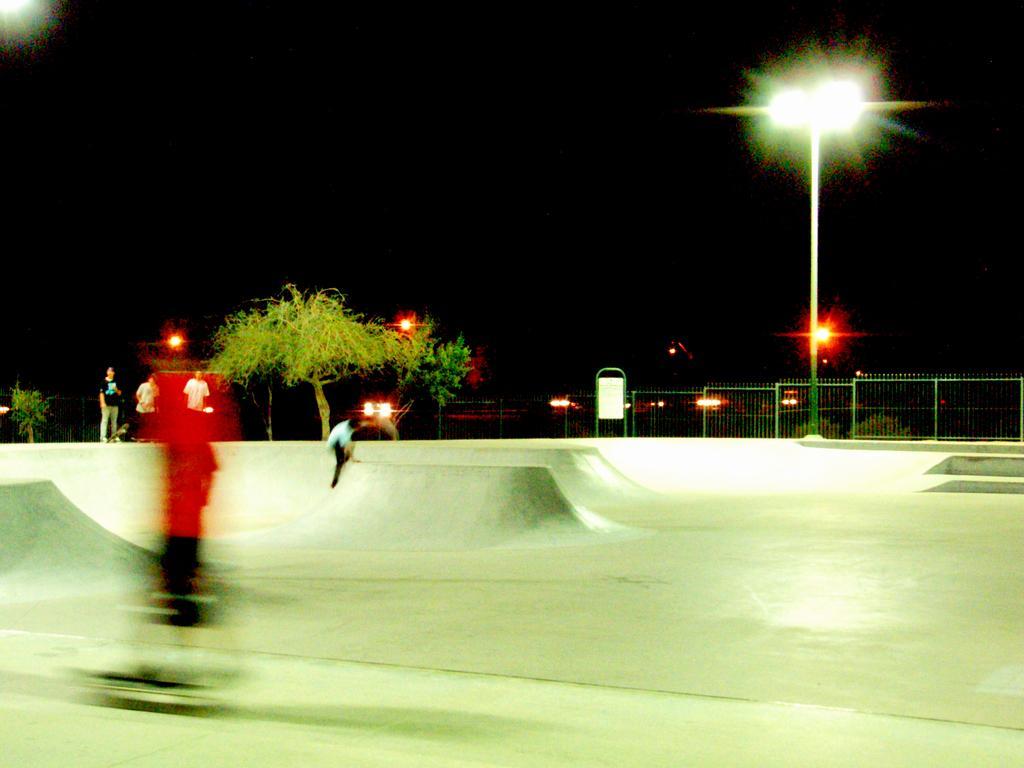How would you summarize this image in a sentence or two? In the center of the image we can see two people are skating. And behind them, we can see a railing, pole with light and a tree. In the background we can see the sky. 